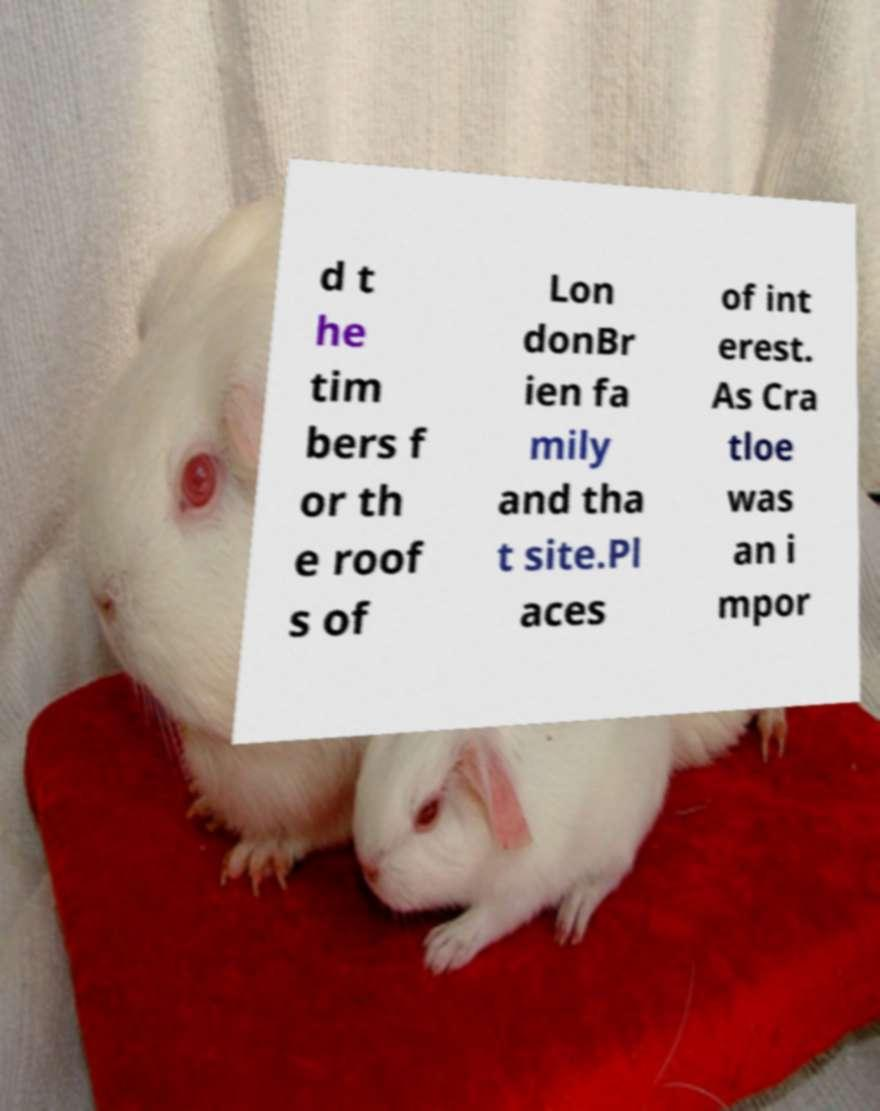Can you accurately transcribe the text from the provided image for me? d t he tim bers f or th e roof s of Lon donBr ien fa mily and tha t site.Pl aces of int erest. As Cra tloe was an i mpor 